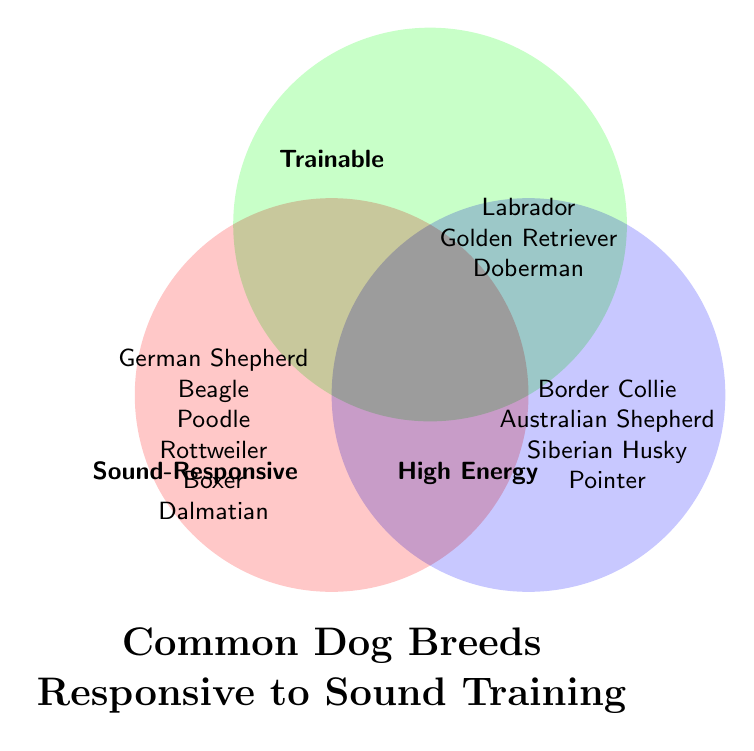Which dog breeds are in the "Sound-Responsive" set? Look at the circle labeled "Sound-Responsive" and list all the breeds inside that circle.
Answer: German Shepherd, Beagle, Poodle, Rottweiler, Boxer, Dalmatian Which dog breeds are in both the "High Energy" and "Trainable" sets? Investigate the intersection area between the "High Energy" and "Trainable" sets.
Answer: Border Collie, Australian Shepherd, Siberian Husky, Pointer How many dog breeds are unique to the "Sound-Responsive" set? Count the number of breeds in the "Sound-Responsive" circle that are not in the overlapping regions with other sets.
Answer: 6 Are there any dog breeds that are common to all three sets? Look for any intersections between all three sets of the Venn diagram.
Answer: No Which set has the fewest unique dog breeds? Count the number of unique breeds in each set and compare.
Answer: Trainable Which dog breeds fall into the "High Energy" set but not in "Sound-Responsive"? Identify breeds in the "High Energy" circle while excluding those in the "Sound-Responsive" circle.
Answer: Border Collie, Australian Shepherd, Siberian Husky, Pointer How many breeds are there in the "Trainable" set? Count the number of breeds listed in the "Trainable" circle.
Answer: 3 What breeds overlap between the "Sound-Responsive" and "Trainable" sets but are not in the "High Energy" set? Check the shared area between "Sound-Responsive" and "Trainable" sets while excluding the "High Energy" set.
Answer: None 